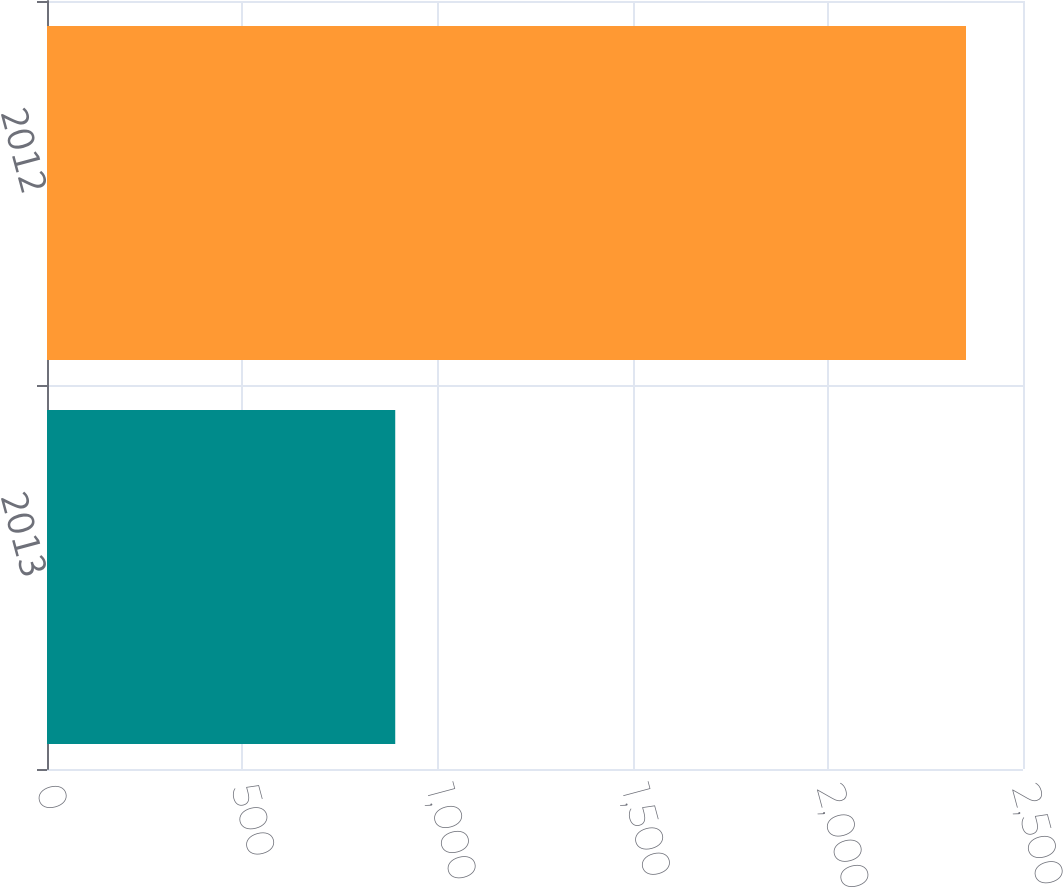<chart> <loc_0><loc_0><loc_500><loc_500><bar_chart><fcel>2013<fcel>2012<nl><fcel>892<fcel>2354<nl></chart> 